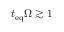<formula> <loc_0><loc_0><loc_500><loc_500>t _ { e q } \Omega \gtrsim 1</formula> 